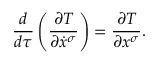<formula> <loc_0><loc_0><loc_500><loc_500>{ \frac { d } { d \tau } } \left ( { \frac { \partial T } { \partial { \dot { x } } ^ { \sigma } } } \right ) = { \frac { \partial T } { \partial x ^ { \sigma } } } .</formula> 